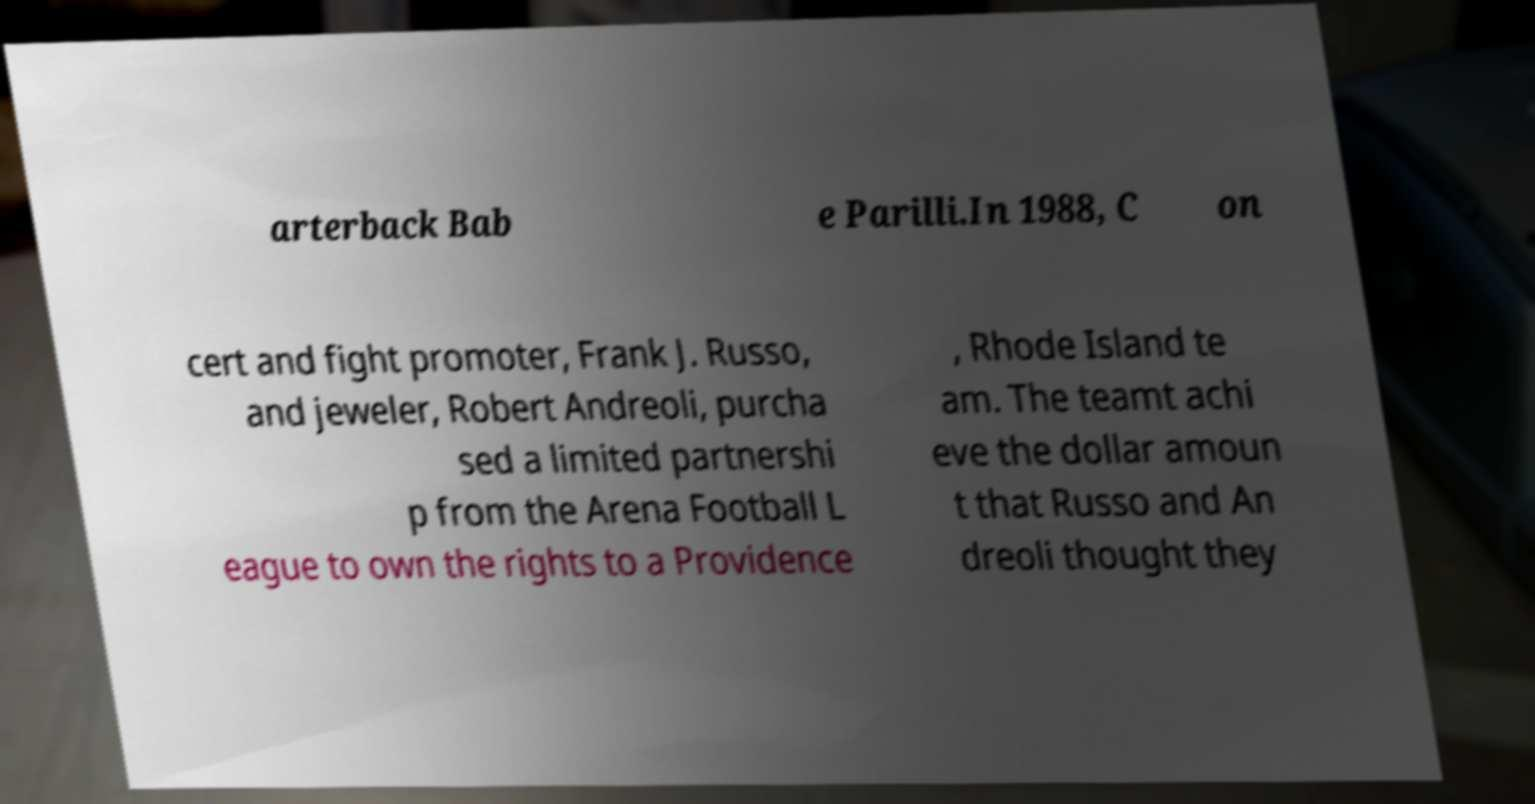Please identify and transcribe the text found in this image. arterback Bab e Parilli.In 1988, C on cert and fight promoter, Frank J. Russo, and jeweler, Robert Andreoli, purcha sed a limited partnershi p from the Arena Football L eague to own the rights to a Providence , Rhode Island te am. The teamt achi eve the dollar amoun t that Russo and An dreoli thought they 